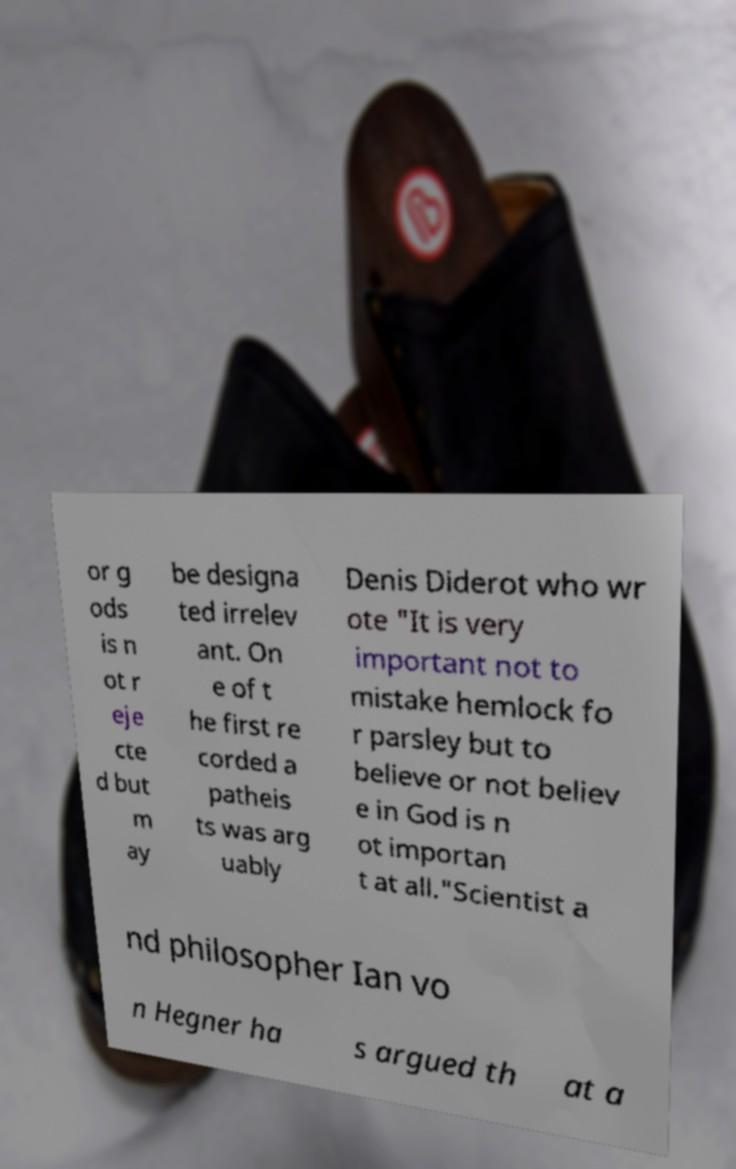Could you assist in decoding the text presented in this image and type it out clearly? or g ods is n ot r eje cte d but m ay be designa ted irrelev ant. On e of t he first re corded a patheis ts was arg uably Denis Diderot who wr ote "It is very important not to mistake hemlock fo r parsley but to believe or not believ e in God is n ot importan t at all."Scientist a nd philosopher Ian vo n Hegner ha s argued th at a 